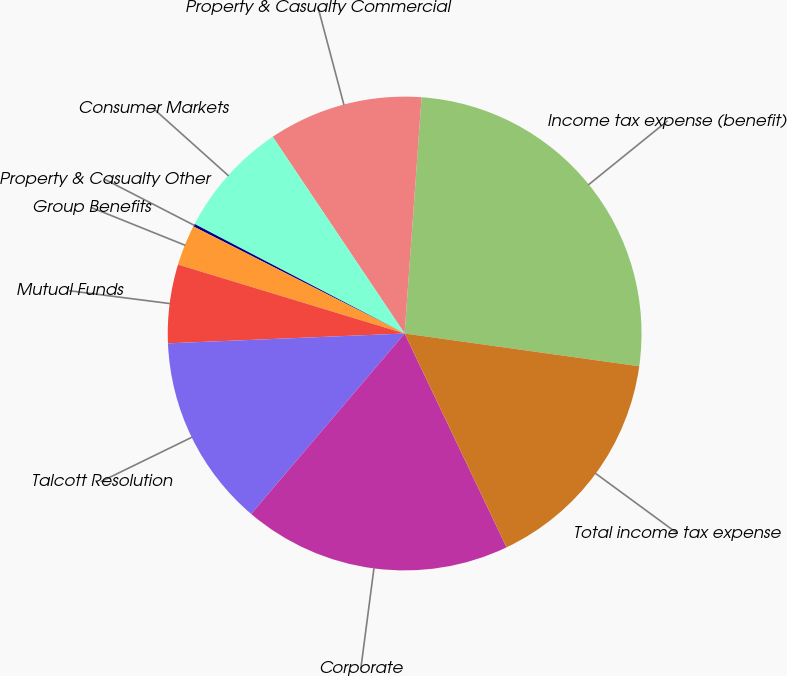<chart> <loc_0><loc_0><loc_500><loc_500><pie_chart><fcel>Income tax expense (benefit)<fcel>Property & Casualty Commercial<fcel>Consumer Markets<fcel>Property & Casualty Other<fcel>Group Benefits<fcel>Mutual Funds<fcel>Talcott Resolution<fcel>Corporate<fcel>Total income tax expense<nl><fcel>26.07%<fcel>10.54%<fcel>7.95%<fcel>0.18%<fcel>2.77%<fcel>5.36%<fcel>13.12%<fcel>18.3%<fcel>15.71%<nl></chart> 